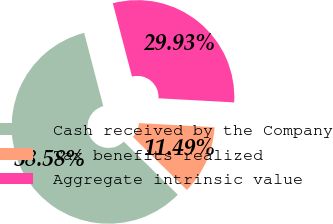Convert chart to OTSL. <chart><loc_0><loc_0><loc_500><loc_500><pie_chart><fcel>Cash received by the Company<fcel>Tax benefits realized<fcel>Aggregate intrinsic value<nl><fcel>58.58%<fcel>11.49%<fcel>29.93%<nl></chart> 